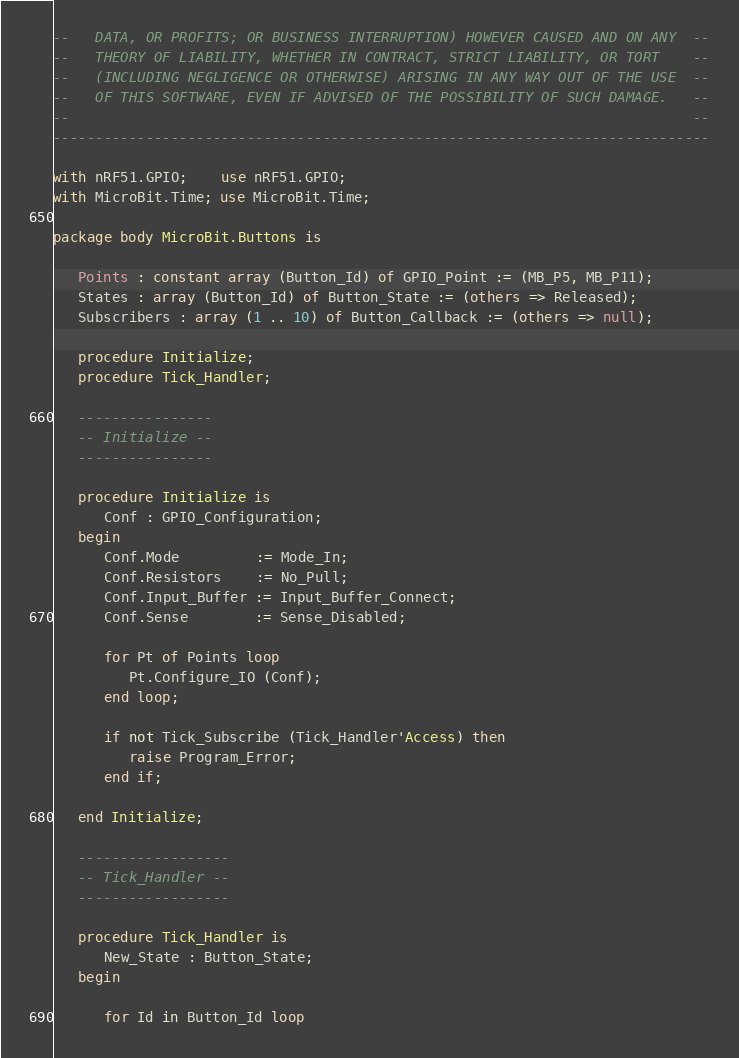<code> <loc_0><loc_0><loc_500><loc_500><_Ada_>--   DATA, OR PROFITS; OR BUSINESS INTERRUPTION) HOWEVER CAUSED AND ON ANY  --
--   THEORY OF LIABILITY, WHETHER IN CONTRACT, STRICT LIABILITY, OR TORT    --
--   (INCLUDING NEGLIGENCE OR OTHERWISE) ARISING IN ANY WAY OUT OF THE USE  --
--   OF THIS SOFTWARE, EVEN IF ADVISED OF THE POSSIBILITY OF SUCH DAMAGE.   --
--                                                                          --
------------------------------------------------------------------------------

with nRF51.GPIO;    use nRF51.GPIO;
with MicroBit.Time; use MicroBit.Time;

package body MicroBit.Buttons is

   Points : constant array (Button_Id) of GPIO_Point := (MB_P5, MB_P11);
   States : array (Button_Id) of Button_State := (others => Released);
   Subscribers : array (1 .. 10) of Button_Callback := (others => null);

   procedure Initialize;
   procedure Tick_Handler;

   ----------------
   -- Initialize --
   ----------------

   procedure Initialize is
      Conf : GPIO_Configuration;
   begin
      Conf.Mode         := Mode_In;
      Conf.Resistors    := No_Pull;
      Conf.Input_Buffer := Input_Buffer_Connect;
      Conf.Sense        := Sense_Disabled;

      for Pt of Points loop
         Pt.Configure_IO (Conf);
      end loop;

      if not Tick_Subscribe (Tick_Handler'Access) then
         raise Program_Error;
      end if;

   end Initialize;

   ------------------
   -- Tick_Handler --
   ------------------

   procedure Tick_Handler is
      New_State : Button_State;
   begin

      for Id in Button_Id loop</code> 